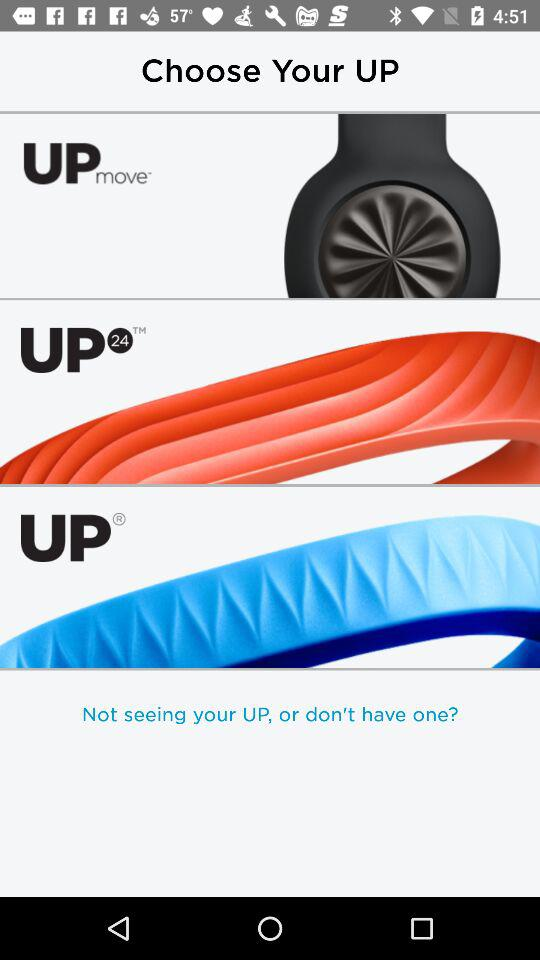How many items have the UP logo?
Answer the question using a single word or phrase. 3 